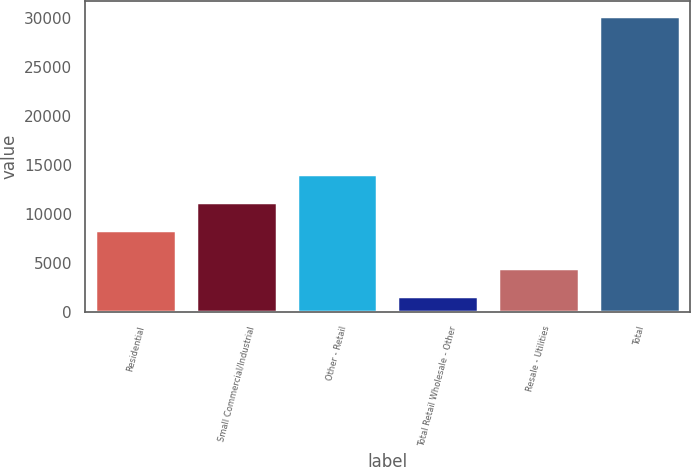Convert chart. <chart><loc_0><loc_0><loc_500><loc_500><bar_chart><fcel>Residential<fcel>Small Commercial/Industrial<fcel>Other - Retail<fcel>Total Retail Wholesale - Other<fcel>Resale - Utilities<fcel>Total<nl><fcel>8317.7<fcel>11186.3<fcel>14054.8<fcel>1566.6<fcel>4435.16<fcel>30252.2<nl></chart> 